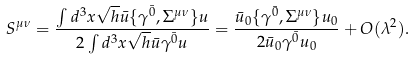<formula> <loc_0><loc_0><loc_500><loc_500>S ^ { \mu \nu } = \frac { \int d ^ { 3 } x \sqrt { h } \bar { u } \{ \gamma ^ { \bar { 0 } } , \Sigma ^ { \mu \nu } \} u } { 2 \int d ^ { 3 } x \sqrt { h } \bar { u } \gamma ^ { \bar { 0 } } u } = \frac { \bar { u } _ { 0 } \{ \gamma ^ { \bar { 0 } } , \Sigma ^ { \mu \nu } \} u _ { 0 } } { 2 \bar { u } _ { 0 } \gamma ^ { \bar { 0 } } u _ { 0 } } + O ( \lambda ^ { 2 } ) .</formula> 